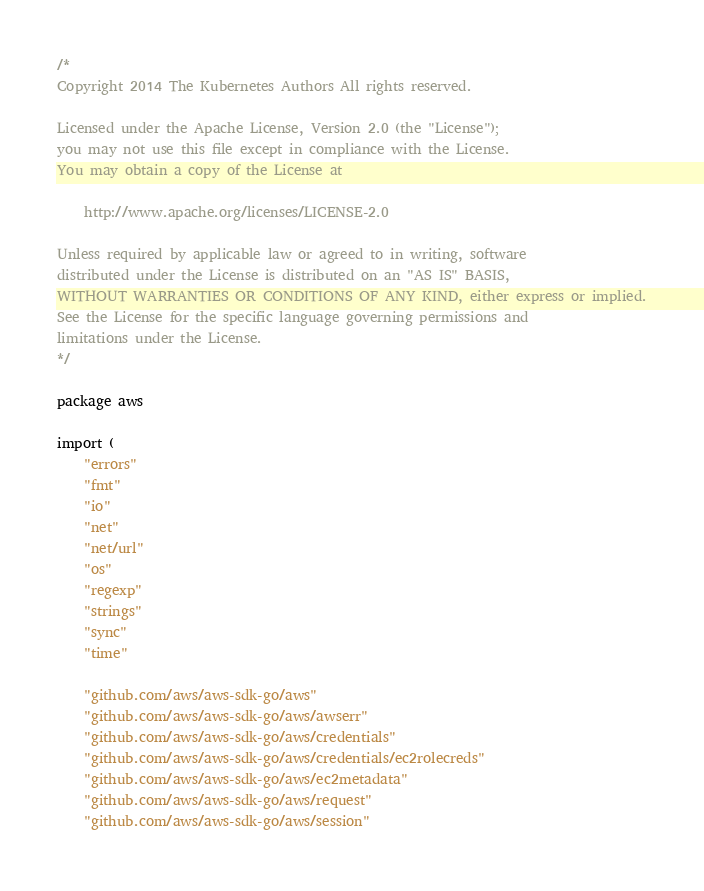<code> <loc_0><loc_0><loc_500><loc_500><_Go_>/*
Copyright 2014 The Kubernetes Authors All rights reserved.

Licensed under the Apache License, Version 2.0 (the "License");
you may not use this file except in compliance with the License.
You may obtain a copy of the License at

    http://www.apache.org/licenses/LICENSE-2.0

Unless required by applicable law or agreed to in writing, software
distributed under the License is distributed on an "AS IS" BASIS,
WITHOUT WARRANTIES OR CONDITIONS OF ANY KIND, either express or implied.
See the License for the specific language governing permissions and
limitations under the License.
*/

package aws

import (
	"errors"
	"fmt"
	"io"
	"net"
	"net/url"
	"os"
	"regexp"
	"strings"
	"sync"
	"time"

	"github.com/aws/aws-sdk-go/aws"
	"github.com/aws/aws-sdk-go/aws/awserr"
	"github.com/aws/aws-sdk-go/aws/credentials"
	"github.com/aws/aws-sdk-go/aws/credentials/ec2rolecreds"
	"github.com/aws/aws-sdk-go/aws/ec2metadata"
	"github.com/aws/aws-sdk-go/aws/request"
	"github.com/aws/aws-sdk-go/aws/session"</code> 